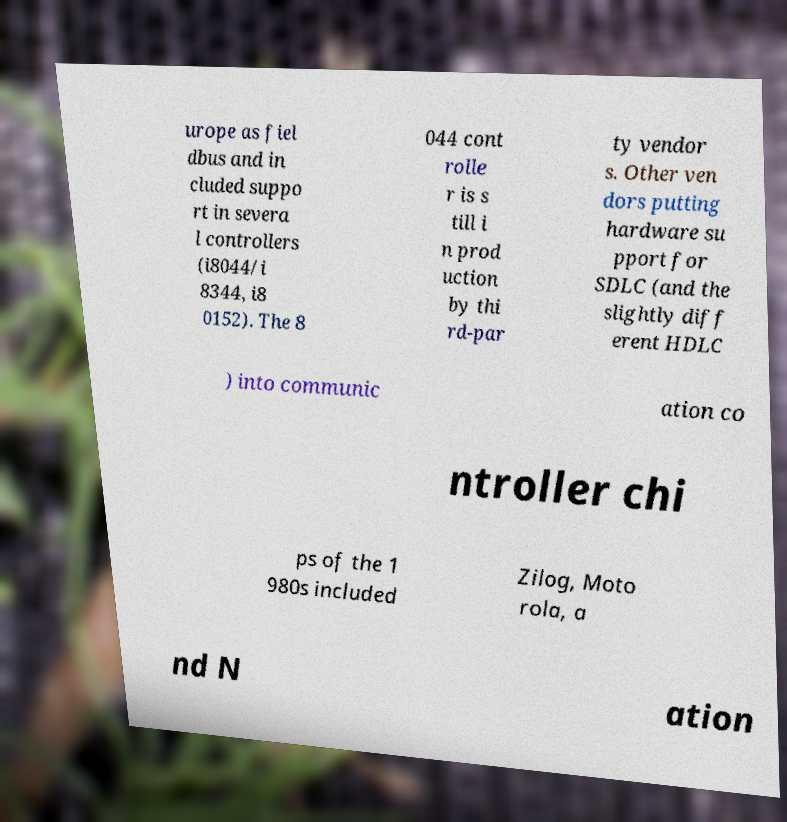I need the written content from this picture converted into text. Can you do that? urope as fiel dbus and in cluded suppo rt in severa l controllers (i8044/i 8344, i8 0152). The 8 044 cont rolle r is s till i n prod uction by thi rd-par ty vendor s. Other ven dors putting hardware su pport for SDLC (and the slightly diff erent HDLC ) into communic ation co ntroller chi ps of the 1 980s included Zilog, Moto rola, a nd N ation 